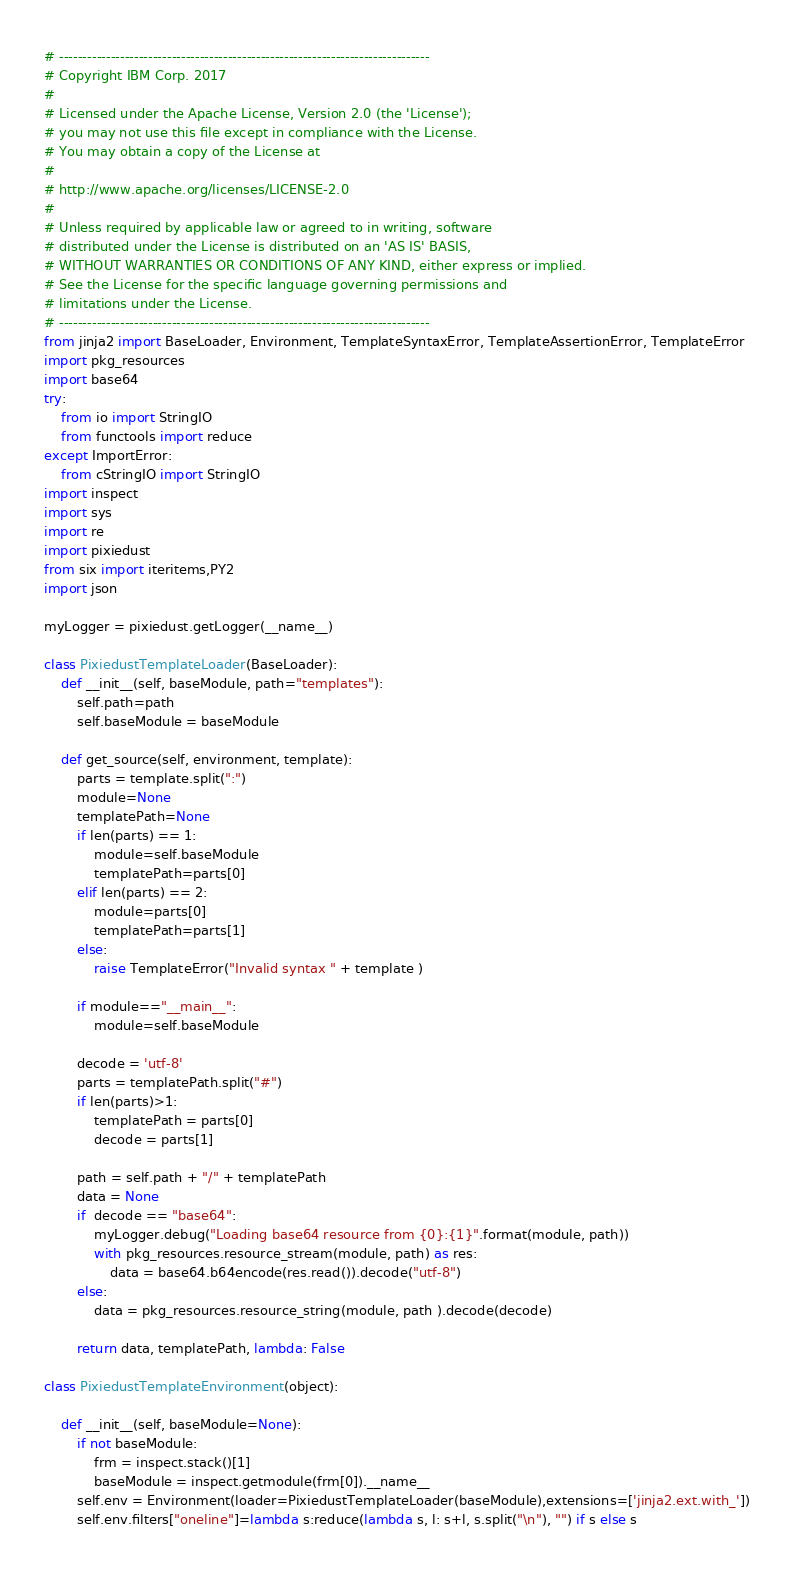<code> <loc_0><loc_0><loc_500><loc_500><_Python_># -------------------------------------------------------------------------------
# Copyright IBM Corp. 2017
# 
# Licensed under the Apache License, Version 2.0 (the 'License');
# you may not use this file except in compliance with the License.
# You may obtain a copy of the License at
# 
# http://www.apache.org/licenses/LICENSE-2.0
# 
# Unless required by applicable law or agreed to in writing, software
# distributed under the License is distributed on an 'AS IS' BASIS,
# WITHOUT WARRANTIES OR CONDITIONS OF ANY KIND, either express or implied.
# See the License for the specific language governing permissions and
# limitations under the License.
# -------------------------------------------------------------------------------
from jinja2 import BaseLoader, Environment, TemplateSyntaxError, TemplateAssertionError, TemplateError
import pkg_resources
import base64
try:
    from io import StringIO    
    from functools import reduce
except ImportError:
    from cStringIO import StringIO
import inspect
import sys
import re
import pixiedust
from six import iteritems,PY2
import json

myLogger = pixiedust.getLogger(__name__)

class PixiedustTemplateLoader(BaseLoader):
    def __init__(self, baseModule, path="templates"):
        self.path=path
        self.baseModule = baseModule

    def get_source(self, environment, template):
        parts = template.split(":")
        module=None
        templatePath=None
        if len(parts) == 1:
            module=self.baseModule
            templatePath=parts[0]
        elif len(parts) == 2:
            module=parts[0]
            templatePath=parts[1]
        else:
            raise TemplateError("Invalid syntax " + template )
        
        if module=="__main__":
            module=self.baseModule
        
        decode = 'utf-8'
        parts = templatePath.split("#")
        if len(parts)>1:
            templatePath = parts[0]
            decode = parts[1]
        
        path = self.path + "/" + templatePath
        data = None
        if  decode == "base64":
            myLogger.debug("Loading base64 resource from {0}:{1}".format(module, path))
            with pkg_resources.resource_stream(module, path) as res:
                data = base64.b64encode(res.read()).decode("utf-8")
        else:
            data = pkg_resources.resource_string(module, path ).decode(decode)
        
        return data, templatePath, lambda: False

class PixiedustTemplateEnvironment(object):
    
    def __init__(self, baseModule=None):
        if not baseModule:
            frm = inspect.stack()[1]
            baseModule = inspect.getmodule(frm[0]).__name__
        self.env = Environment(loader=PixiedustTemplateLoader(baseModule),extensions=['jinja2.ext.with_'])
        self.env.filters["oneline"]=lambda s:reduce(lambda s, l: s+l, s.split("\n"), "") if s else s</code> 